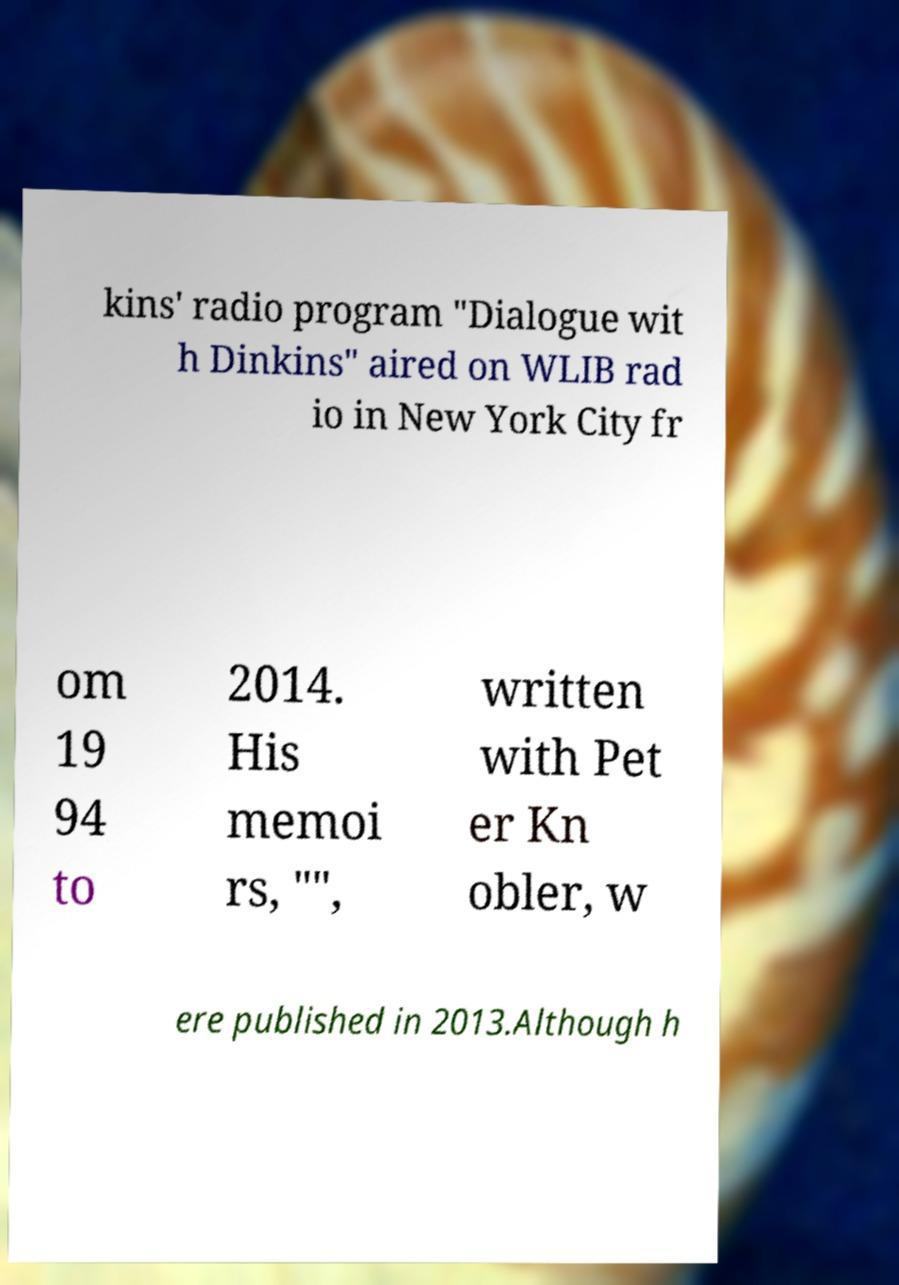Could you assist in decoding the text presented in this image and type it out clearly? kins' radio program "Dialogue wit h Dinkins" aired on WLIB rad io in New York City fr om 19 94 to 2014. His memoi rs, "", written with Pet er Kn obler, w ere published in 2013.Although h 